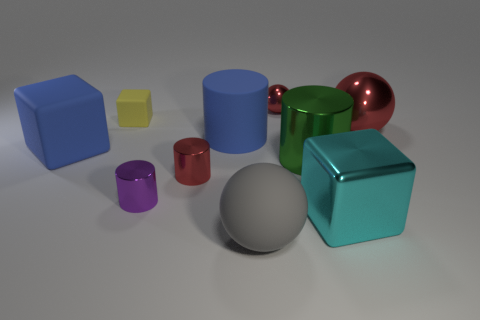Is the purple cylinder the same size as the yellow cube?
Your answer should be very brief. Yes. There is a big object that is on the left side of the big blue rubber cylinder; what is its shape?
Give a very brief answer. Cube. The large sphere that is behind the big object in front of the large cyan metal block is what color?
Provide a succinct answer. Red. Do the red metal thing to the right of the large green thing and the tiny metal thing that is behind the large matte cylinder have the same shape?
Offer a very short reply. Yes. What shape is the green thing that is the same size as the rubber cylinder?
Make the answer very short. Cylinder. The tiny object that is the same material as the big gray sphere is what color?
Offer a terse response. Yellow. There is a tiny purple object; does it have the same shape as the small red thing that is behind the red cylinder?
Provide a succinct answer. No. What material is the cube that is the same color as the rubber cylinder?
Provide a succinct answer. Rubber. There is a block that is the same size as the purple cylinder; what is it made of?
Keep it short and to the point. Rubber. Are there any big matte things of the same color as the metallic block?
Make the answer very short. No. 